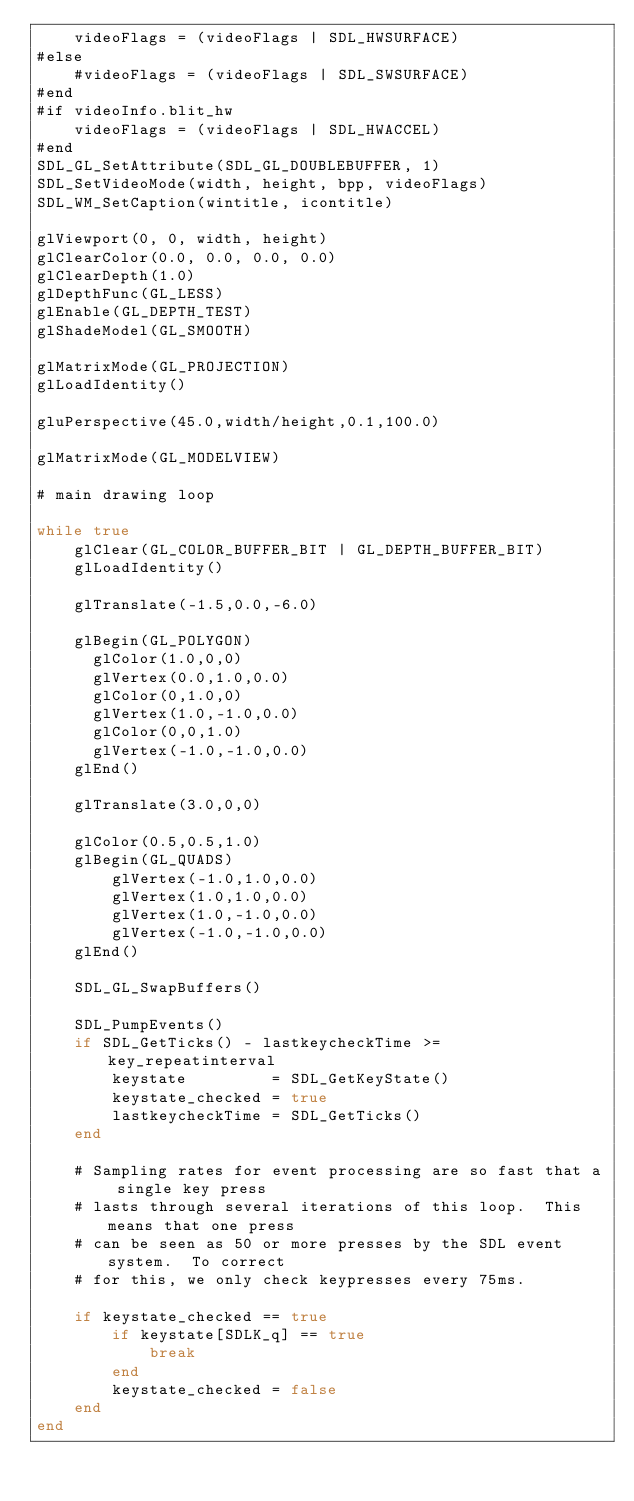<code> <loc_0><loc_0><loc_500><loc_500><_Julia_>    videoFlags = (videoFlags | SDL_HWSURFACE)
#else
    #videoFlags = (videoFlags | SDL_SWSURFACE)
#end
#if videoInfo.blit_hw
    videoFlags = (videoFlags | SDL_HWACCEL)
#end
SDL_GL_SetAttribute(SDL_GL_DOUBLEBUFFER, 1)
SDL_SetVideoMode(width, height, bpp, videoFlags)
SDL_WM_SetCaption(wintitle, icontitle)

glViewport(0, 0, width, height)
glClearColor(0.0, 0.0, 0.0, 0.0)
glClearDepth(1.0)
glDepthFunc(GL_LESS)
glEnable(GL_DEPTH_TEST)
glShadeModel(GL_SMOOTH)

glMatrixMode(GL_PROJECTION)
glLoadIdentity()

gluPerspective(45.0,width/height,0.1,100.0)

glMatrixMode(GL_MODELVIEW)

# main drawing loop

while true
    glClear(GL_COLOR_BUFFER_BIT | GL_DEPTH_BUFFER_BIT)
    glLoadIdentity()

    glTranslate(-1.5,0.0,-6.0)

    glBegin(GL_POLYGON)
      glColor(1.0,0,0)
      glVertex(0.0,1.0,0.0)
      glColor(0,1.0,0)
      glVertex(1.0,-1.0,0.0)
      glColor(0,0,1.0)
      glVertex(-1.0,-1.0,0.0)
    glEnd()

    glTranslate(3.0,0,0)

    glColor(0.5,0.5,1.0)
    glBegin(GL_QUADS)
        glVertex(-1.0,1.0,0.0)
        glVertex(1.0,1.0,0.0)
        glVertex(1.0,-1.0,0.0)
        glVertex(-1.0,-1.0,0.0)
    glEnd()

    SDL_GL_SwapBuffers()

    SDL_PumpEvents()
    if SDL_GetTicks() - lastkeycheckTime >= key_repeatinterval
        keystate         = SDL_GetKeyState()
        keystate_checked = true
        lastkeycheckTime = SDL_GetTicks()
    end

    # Sampling rates for event processing are so fast that a single key press
    # lasts through several iterations of this loop.  This means that one press
    # can be seen as 50 or more presses by the SDL event system.  To correct
    # for this, we only check keypresses every 75ms.

    if keystate_checked == true
        if keystate[SDLK_q] == true
            break
        end
        keystate_checked = false
    end
end
</code> 